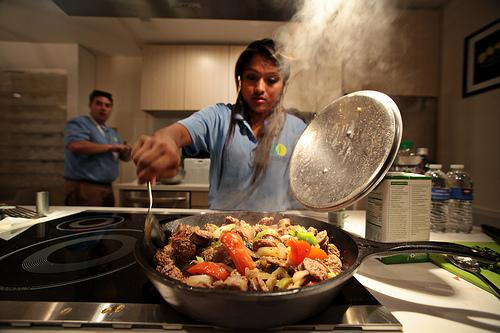What are the ingredients being cooked in the pan? Chunks of meat, red and green peppers, and beef are being cooked in the pan. Identify the activity taking place in the kitchen and what dish is being prepared. A girl is cooking beef stir fry on a smooth top stove, stirring the pan full of food and holding a large pot lid. What is the color and material of the handle on the dishwasher? The handle of the dishwasher is silver in color. How many people are in the kitchen and describe what they are wearing? There are two people in the kitchen, both wearing blue shirts. Find out if there is any art in the scene and describe it. There is a picture hanging on the wall in the scene. Mention any peculiar objects on the counter. There are two bottles of water and a green white box on the counter. Describe the man in the image. The man is standing beside cabinets, wearing a blue shirt, and watching the food preparation. Can you point out any specific type of pan for cooking the food and also what is unique about the stove? The food is being cooked in an iron skillet full of stir fry, and it's a black gas stove range. What objects are being held by the woman in the image? The woman is holding a spoon and a large pot lid in her hands. Analyze the interaction between the man and the woman in the kitchen. The man is observing the woman as she cooks, while she focuses on stirring the pan and holding the pot lid. Where is the orange pot located next to the skillet? No, it's not mentioned in the image. Where is the woman stirring food with a blue spoon? There is a woman stirring food, but there is no mention of the spoon's color being blue. The instruction is misleading as it assumes the spoon is blue. 